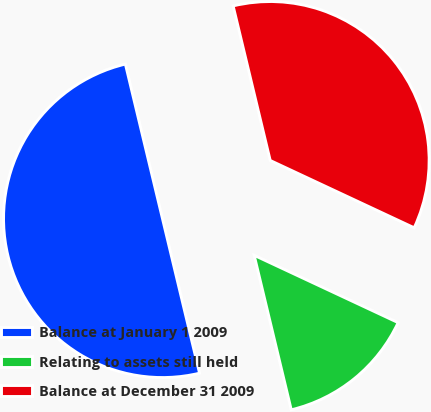Convert chart to OTSL. <chart><loc_0><loc_0><loc_500><loc_500><pie_chart><fcel>Balance at January 1 2009<fcel>Relating to assets still held<fcel>Balance at December 31 2009<nl><fcel>50.0%<fcel>14.29%<fcel>35.71%<nl></chart> 